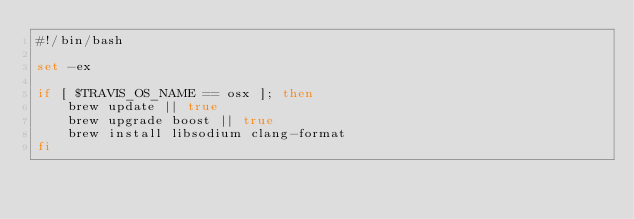Convert code to text. <code><loc_0><loc_0><loc_500><loc_500><_Bash_>#!/bin/bash

set -ex

if [ $TRAVIS_OS_NAME == osx ]; then
    brew update || true
    brew upgrade boost || true
    brew install libsodium clang-format
fi
</code> 